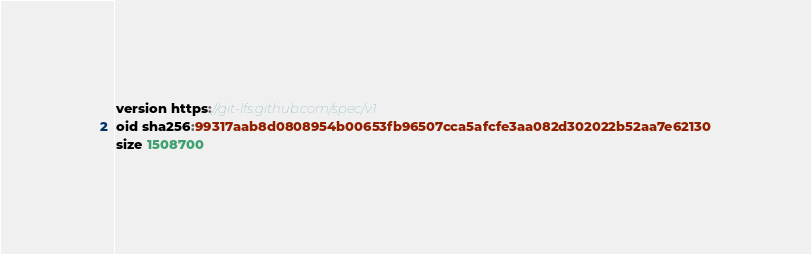Convert code to text. <code><loc_0><loc_0><loc_500><loc_500><_TypeScript_>version https://git-lfs.github.com/spec/v1
oid sha256:99317aab8d0808954b00653fb96507cca5afcfe3aa082d302022b52aa7e62130
size 1508700
</code> 